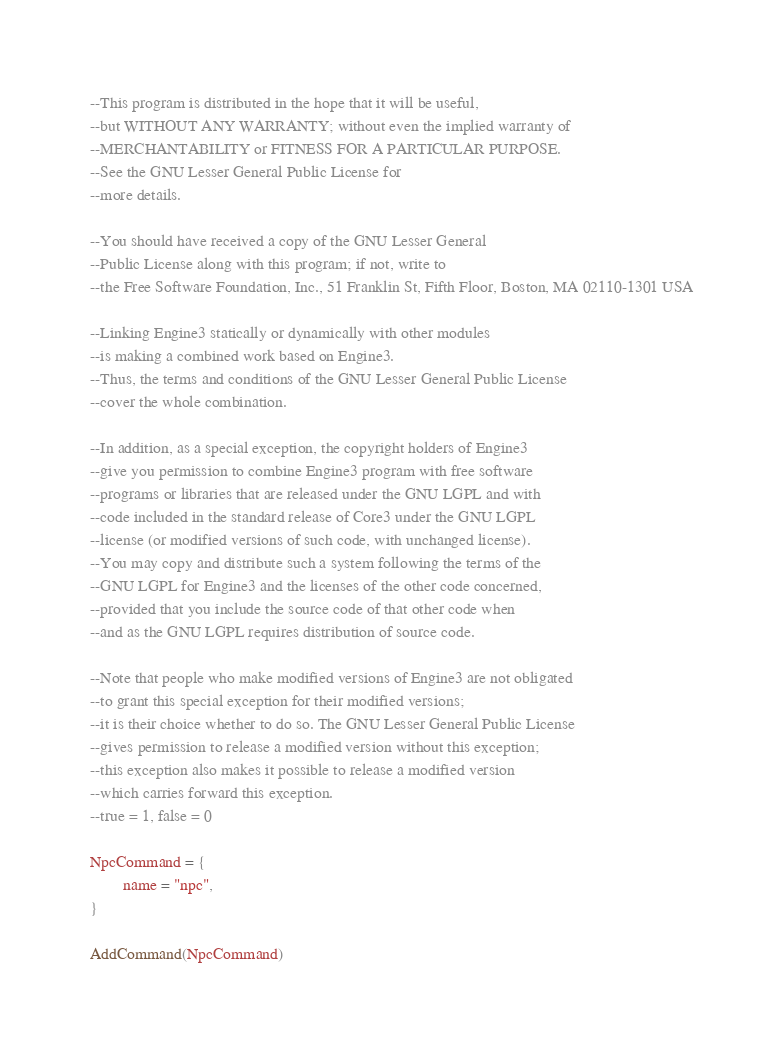Convert code to text. <code><loc_0><loc_0><loc_500><loc_500><_Lua_>--This program is distributed in the hope that it will be useful,
--but WITHOUT ANY WARRANTY; without even the implied warranty of
--MERCHANTABILITY or FITNESS FOR A PARTICULAR PURPOSE.
--See the GNU Lesser General Public License for
--more details.

--You should have received a copy of the GNU Lesser General
--Public License along with this program; if not, write to
--the Free Software Foundation, Inc., 51 Franklin St, Fifth Floor, Boston, MA 02110-1301 USA

--Linking Engine3 statically or dynamically with other modules
--is making a combined work based on Engine3.
--Thus, the terms and conditions of the GNU Lesser General Public License
--cover the whole combination.

--In addition, as a special exception, the copyright holders of Engine3
--give you permission to combine Engine3 program with free software
--programs or libraries that are released under the GNU LGPL and with
--code included in the standard release of Core3 under the GNU LGPL
--license (or modified versions of such code, with unchanged license).
--You may copy and distribute such a system following the terms of the
--GNU LGPL for Engine3 and the licenses of the other code concerned,
--provided that you include the source code of that other code when
--and as the GNU LGPL requires distribution of source code.

--Note that people who make modified versions of Engine3 are not obligated
--to grant this special exception for their modified versions;
--it is their choice whether to do so. The GNU Lesser General Public License
--gives permission to release a modified version without this exception;
--this exception also makes it possible to release a modified version
--which carries forward this exception.
--true = 1, false = 0

NpcCommand = {
        name = "npc",
}

AddCommand(NpcCommand)

</code> 